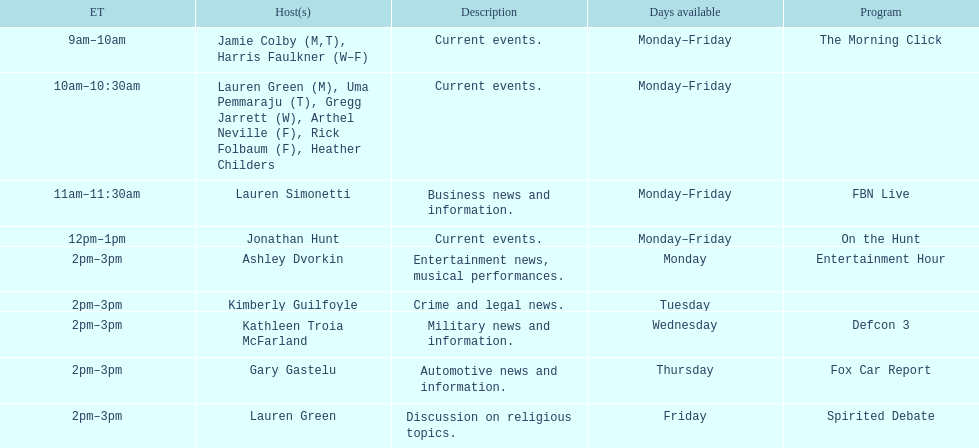What is the first show to play on monday mornings? The Morning Click. 